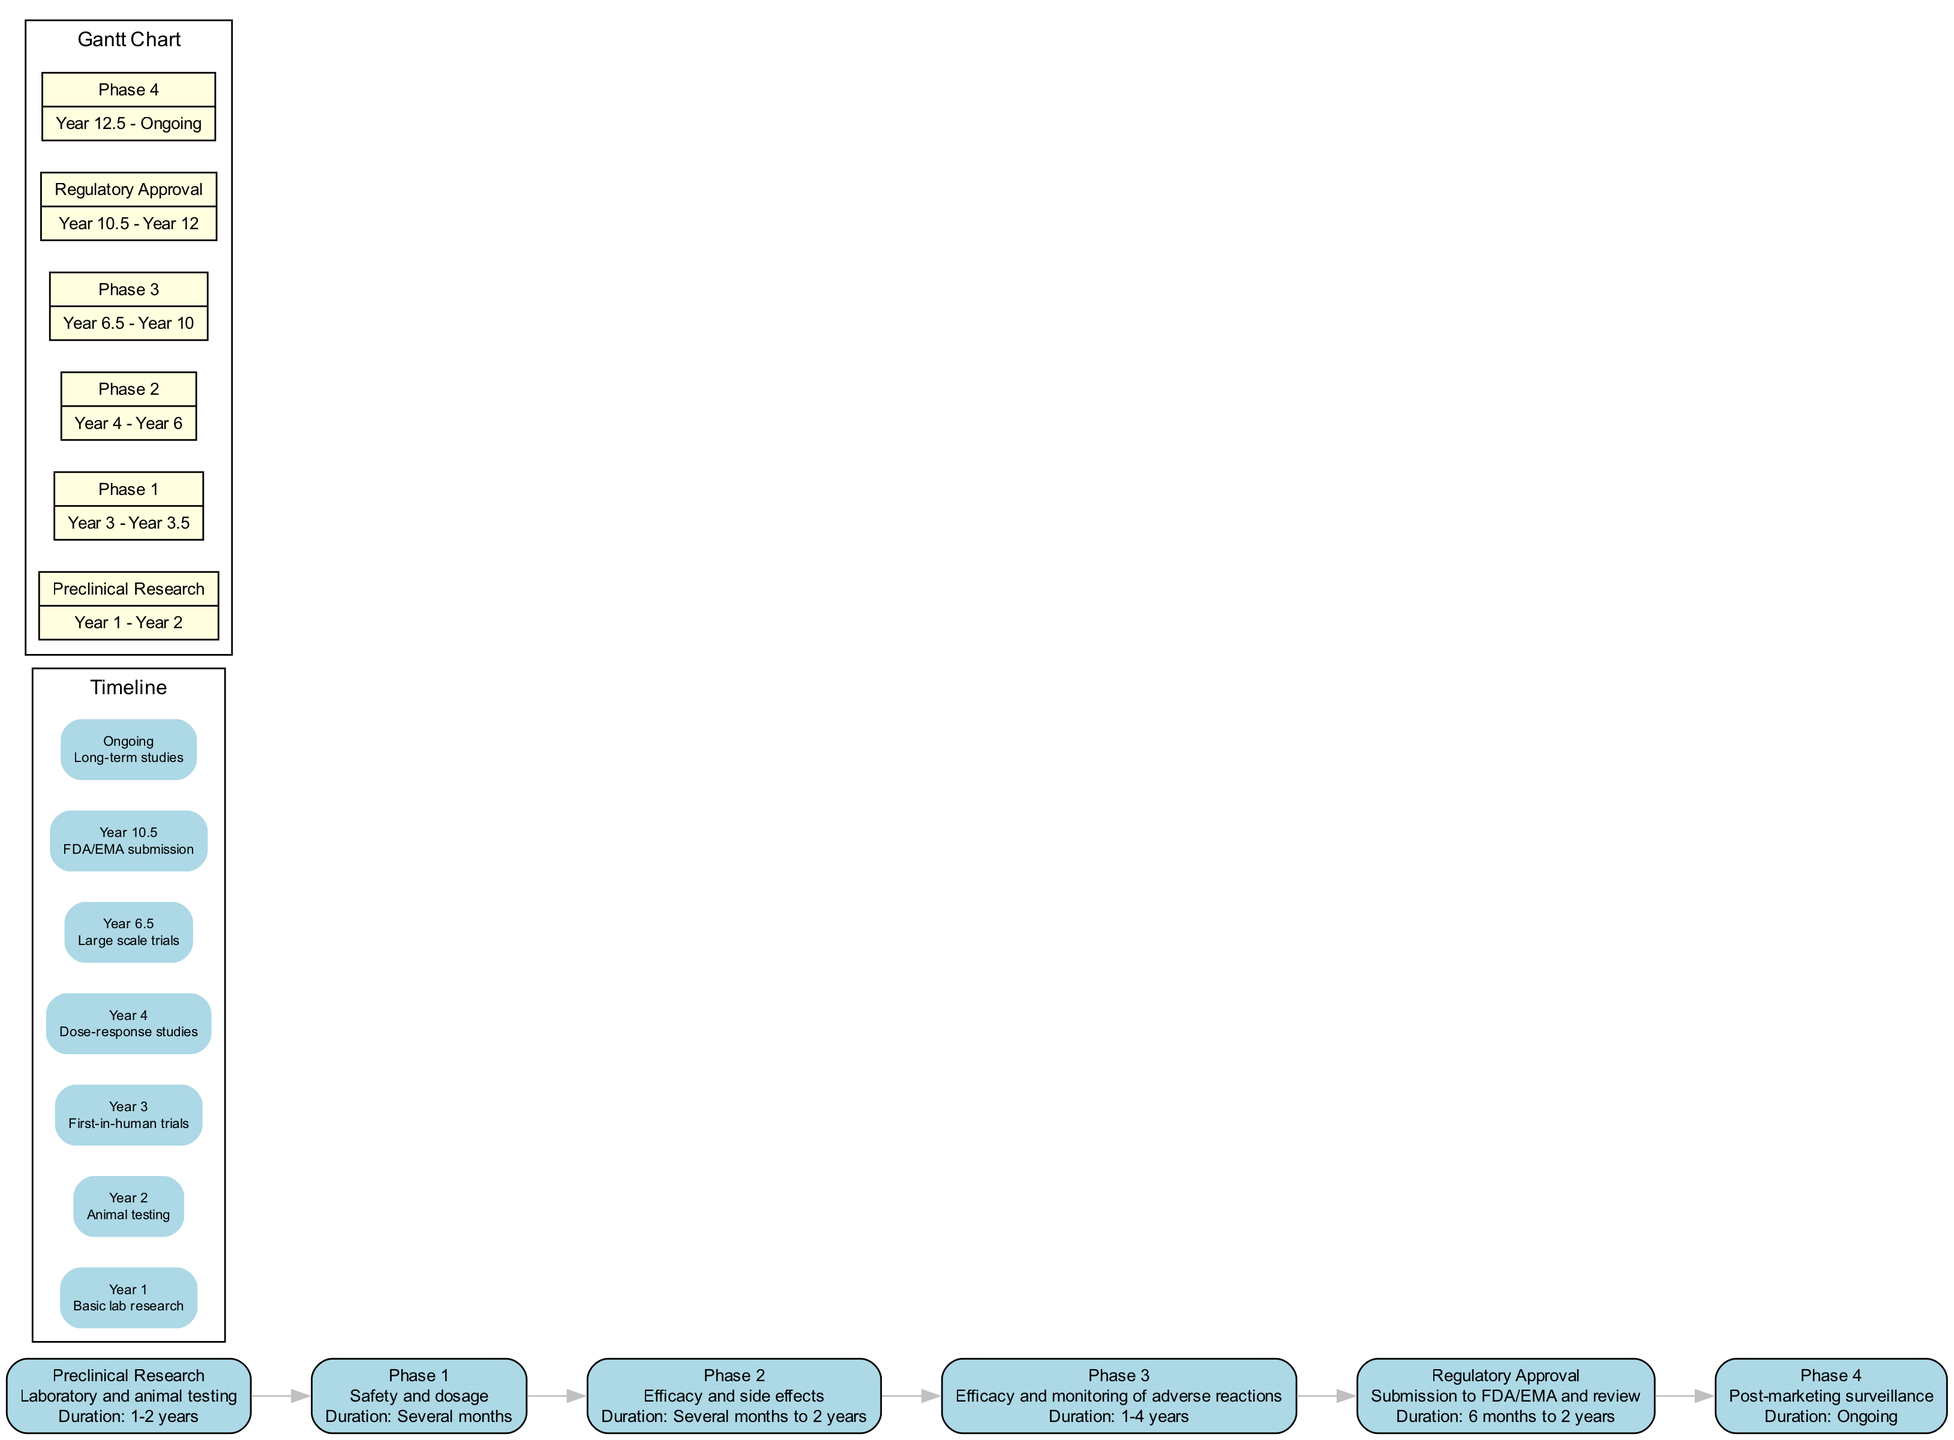What is the duration of Phase 1? According to the diagram, Phase 1 lasts "Several months."
Answer: Several months How many phases are shown in the diagram? The diagram lists a total of 6 phases, which are Preclinical Research, Phase 1, Phase 2, Phase 3, Regulatory Approval, and Phase 4.
Answer: 6 What is the first milestone in the timeline for Preclinical Research? The first milestone listed in the timeline for Preclinical Research is "Basic lab research," which occurs in Year 1.
Answer: Basic lab research Which phase is responsible for large scale trials? The diagram indicates that "Phase 3," with a milestone of "Large scale trials" in Year 6.5, is responsible for that aspect.
Answer: Phase 3 How long is the Regulatory Approval phase scheduled to take? The Regulatory Approval phase is scheduled to take between "6 months to 2 years," as mentioned in the description.
Answer: 6 months to 2 years Which task in the Gantt chart follows Phase 2? According to the Gantt chart, the task that follows Phase 2 is "Phase 3," which starts at Year 6.5.
Answer: Phase 3 What is the duration range for the Preclinical Research phase? The diagram specifies that the duration for the Preclinical Research phase is "1-2 years."
Answer: 1-2 years What is the last milestone listed in the timeline? The last milestone in the timeline is "Long-term studies," which is ongoing during Phase 4.
Answer: Long-term studies 